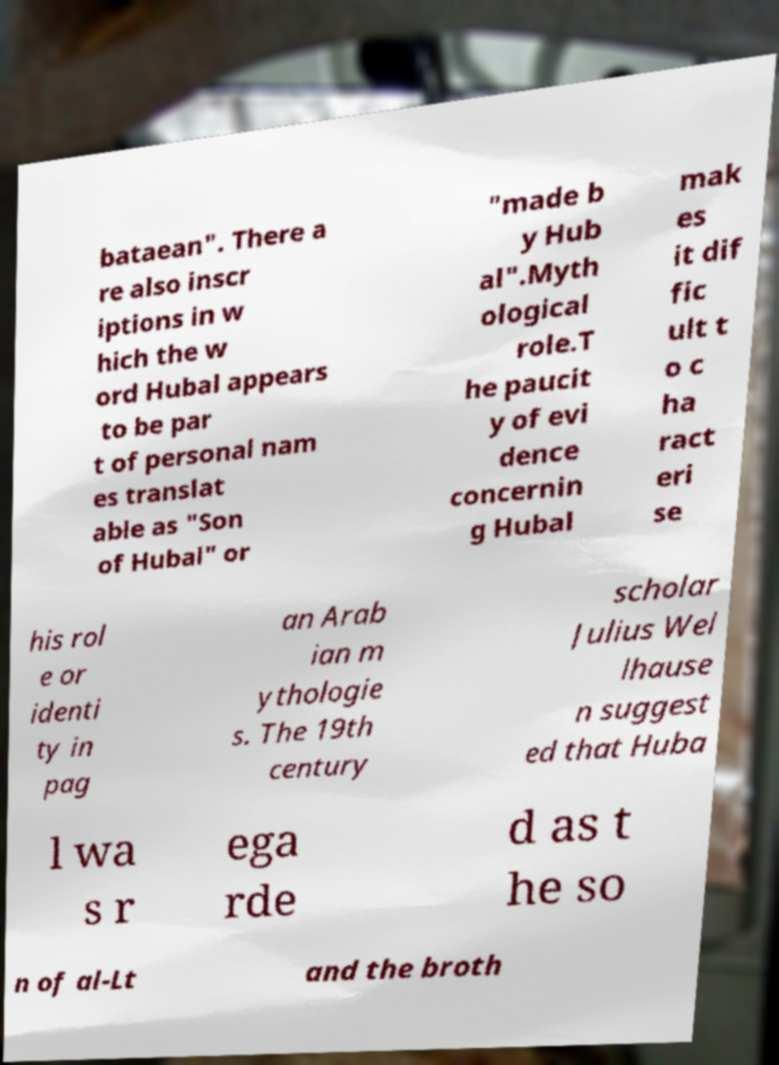I need the written content from this picture converted into text. Can you do that? bataean". There a re also inscr iptions in w hich the w ord Hubal appears to be par t of personal nam es translat able as "Son of Hubal" or "made b y Hub al".Myth ological role.T he paucit y of evi dence concernin g Hubal mak es it dif fic ult t o c ha ract eri se his rol e or identi ty in pag an Arab ian m ythologie s. The 19th century scholar Julius Wel lhause n suggest ed that Huba l wa s r ega rde d as t he so n of al-Lt and the broth 